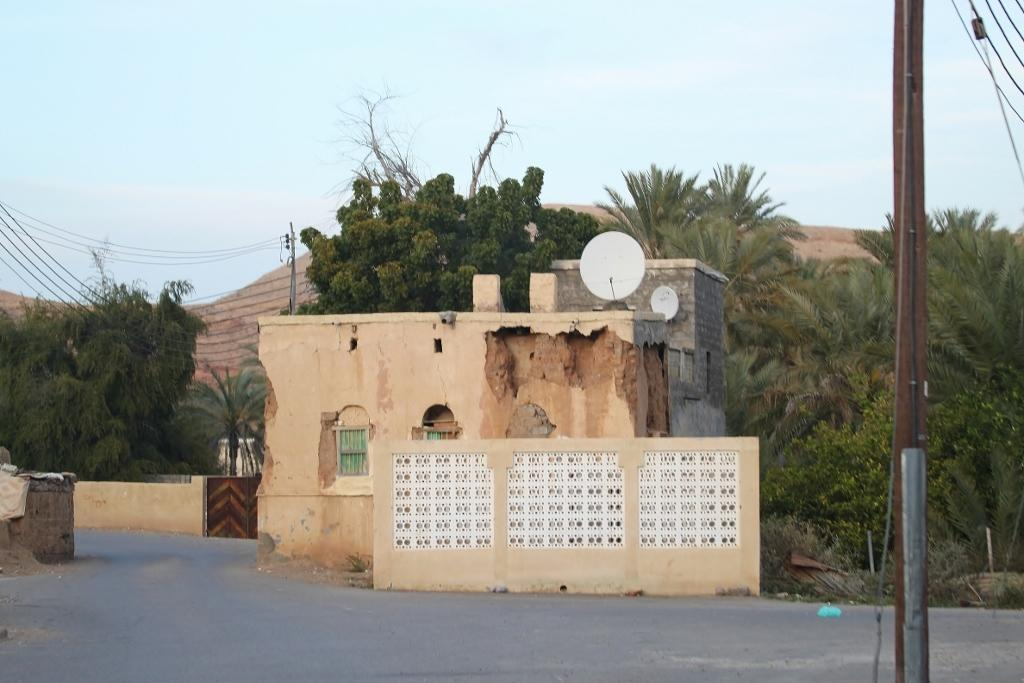What type of structures can be seen in the image? There are houses in the image. What architectural elements are present in the image? There are walls in the image. What openings can be seen in the structures? There are windows in the image. What type of vegetation is present in the image? There are trees and plants in the image. What utility infrastructure can be seen in the image? There are poles with wires in the image. What is at the bottom of the image? There is a road at the bottom of the image. What can be seen in the background of the image? The sky is visible in the background of the image. How many gallons of milk are being transported by the carriage in the image? There is no carriage or milk present in the image. How many bikes are parked near the trees in the image? There are no bikes present in the image. 